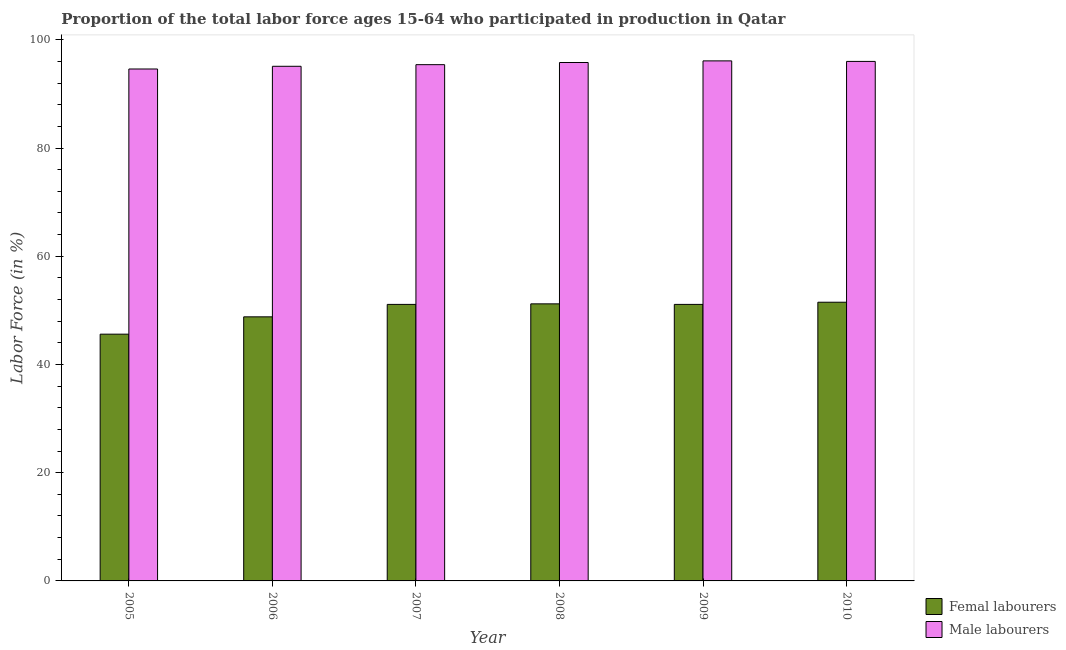How many bars are there on the 2nd tick from the left?
Offer a very short reply. 2. How many bars are there on the 4th tick from the right?
Your answer should be compact. 2. What is the label of the 2nd group of bars from the left?
Your answer should be compact. 2006. What is the percentage of male labour force in 2007?
Your answer should be very brief. 95.4. Across all years, what is the maximum percentage of female labor force?
Keep it short and to the point. 51.5. Across all years, what is the minimum percentage of male labour force?
Make the answer very short. 94.6. In which year was the percentage of male labour force maximum?
Your response must be concise. 2009. What is the total percentage of female labor force in the graph?
Your answer should be very brief. 299.3. What is the difference between the percentage of female labor force in 2008 and the percentage of male labour force in 2010?
Your answer should be very brief. -0.3. What is the average percentage of male labour force per year?
Your response must be concise. 95.5. What is the ratio of the percentage of female labor force in 2006 to that in 2007?
Provide a succinct answer. 0.95. Is the percentage of male labour force in 2005 less than that in 2006?
Provide a short and direct response. Yes. Is the difference between the percentage of male labour force in 2005 and 2008 greater than the difference between the percentage of female labor force in 2005 and 2008?
Make the answer very short. No. What is the difference between the highest and the second highest percentage of female labor force?
Your answer should be very brief. 0.3. What is the difference between the highest and the lowest percentage of female labor force?
Provide a succinct answer. 5.9. Is the sum of the percentage of female labor force in 2007 and 2008 greater than the maximum percentage of male labour force across all years?
Your answer should be very brief. Yes. What does the 2nd bar from the left in 2008 represents?
Your answer should be compact. Male labourers. What does the 1st bar from the right in 2007 represents?
Your answer should be compact. Male labourers. How many bars are there?
Keep it short and to the point. 12. Are all the bars in the graph horizontal?
Provide a succinct answer. No. How many years are there in the graph?
Offer a terse response. 6. Are the values on the major ticks of Y-axis written in scientific E-notation?
Keep it short and to the point. No. Does the graph contain grids?
Offer a very short reply. No. Where does the legend appear in the graph?
Your answer should be compact. Bottom right. How many legend labels are there?
Keep it short and to the point. 2. How are the legend labels stacked?
Ensure brevity in your answer.  Vertical. What is the title of the graph?
Your answer should be very brief. Proportion of the total labor force ages 15-64 who participated in production in Qatar. What is the label or title of the X-axis?
Ensure brevity in your answer.  Year. What is the label or title of the Y-axis?
Offer a terse response. Labor Force (in %). What is the Labor Force (in %) in Femal labourers in 2005?
Keep it short and to the point. 45.6. What is the Labor Force (in %) in Male labourers in 2005?
Provide a short and direct response. 94.6. What is the Labor Force (in %) in Femal labourers in 2006?
Make the answer very short. 48.8. What is the Labor Force (in %) of Male labourers in 2006?
Provide a succinct answer. 95.1. What is the Labor Force (in %) of Femal labourers in 2007?
Your response must be concise. 51.1. What is the Labor Force (in %) of Male labourers in 2007?
Ensure brevity in your answer.  95.4. What is the Labor Force (in %) in Femal labourers in 2008?
Ensure brevity in your answer.  51.2. What is the Labor Force (in %) in Male labourers in 2008?
Provide a short and direct response. 95.8. What is the Labor Force (in %) of Femal labourers in 2009?
Your answer should be compact. 51.1. What is the Labor Force (in %) of Male labourers in 2009?
Provide a succinct answer. 96.1. What is the Labor Force (in %) of Femal labourers in 2010?
Your response must be concise. 51.5. What is the Labor Force (in %) in Male labourers in 2010?
Your response must be concise. 96. Across all years, what is the maximum Labor Force (in %) in Femal labourers?
Make the answer very short. 51.5. Across all years, what is the maximum Labor Force (in %) in Male labourers?
Your response must be concise. 96.1. Across all years, what is the minimum Labor Force (in %) of Femal labourers?
Your response must be concise. 45.6. Across all years, what is the minimum Labor Force (in %) in Male labourers?
Keep it short and to the point. 94.6. What is the total Labor Force (in %) in Femal labourers in the graph?
Provide a succinct answer. 299.3. What is the total Labor Force (in %) in Male labourers in the graph?
Your response must be concise. 573. What is the difference between the Labor Force (in %) in Femal labourers in 2005 and that in 2006?
Keep it short and to the point. -3.2. What is the difference between the Labor Force (in %) in Male labourers in 2005 and that in 2006?
Keep it short and to the point. -0.5. What is the difference between the Labor Force (in %) in Femal labourers in 2005 and that in 2007?
Your answer should be very brief. -5.5. What is the difference between the Labor Force (in %) of Femal labourers in 2005 and that in 2008?
Your answer should be very brief. -5.6. What is the difference between the Labor Force (in %) in Male labourers in 2005 and that in 2008?
Keep it short and to the point. -1.2. What is the difference between the Labor Force (in %) in Male labourers in 2005 and that in 2009?
Provide a short and direct response. -1.5. What is the difference between the Labor Force (in %) of Male labourers in 2006 and that in 2007?
Give a very brief answer. -0.3. What is the difference between the Labor Force (in %) of Femal labourers in 2006 and that in 2008?
Provide a succinct answer. -2.4. What is the difference between the Labor Force (in %) in Femal labourers in 2006 and that in 2009?
Your response must be concise. -2.3. What is the difference between the Labor Force (in %) of Male labourers in 2006 and that in 2009?
Your answer should be very brief. -1. What is the difference between the Labor Force (in %) of Femal labourers in 2006 and that in 2010?
Offer a very short reply. -2.7. What is the difference between the Labor Force (in %) of Male labourers in 2007 and that in 2009?
Offer a terse response. -0.7. What is the difference between the Labor Force (in %) of Femal labourers in 2007 and that in 2010?
Offer a terse response. -0.4. What is the difference between the Labor Force (in %) of Male labourers in 2007 and that in 2010?
Your answer should be compact. -0.6. What is the difference between the Labor Force (in %) of Femal labourers in 2008 and that in 2009?
Keep it short and to the point. 0.1. What is the difference between the Labor Force (in %) in Male labourers in 2008 and that in 2009?
Provide a succinct answer. -0.3. What is the difference between the Labor Force (in %) in Femal labourers in 2008 and that in 2010?
Provide a short and direct response. -0.3. What is the difference between the Labor Force (in %) in Male labourers in 2008 and that in 2010?
Your answer should be compact. -0.2. What is the difference between the Labor Force (in %) in Male labourers in 2009 and that in 2010?
Give a very brief answer. 0.1. What is the difference between the Labor Force (in %) in Femal labourers in 2005 and the Labor Force (in %) in Male labourers in 2006?
Your response must be concise. -49.5. What is the difference between the Labor Force (in %) in Femal labourers in 2005 and the Labor Force (in %) in Male labourers in 2007?
Your answer should be very brief. -49.8. What is the difference between the Labor Force (in %) in Femal labourers in 2005 and the Labor Force (in %) in Male labourers in 2008?
Keep it short and to the point. -50.2. What is the difference between the Labor Force (in %) in Femal labourers in 2005 and the Labor Force (in %) in Male labourers in 2009?
Provide a short and direct response. -50.5. What is the difference between the Labor Force (in %) in Femal labourers in 2005 and the Labor Force (in %) in Male labourers in 2010?
Offer a terse response. -50.4. What is the difference between the Labor Force (in %) in Femal labourers in 2006 and the Labor Force (in %) in Male labourers in 2007?
Make the answer very short. -46.6. What is the difference between the Labor Force (in %) in Femal labourers in 2006 and the Labor Force (in %) in Male labourers in 2008?
Make the answer very short. -47. What is the difference between the Labor Force (in %) in Femal labourers in 2006 and the Labor Force (in %) in Male labourers in 2009?
Your answer should be very brief. -47.3. What is the difference between the Labor Force (in %) of Femal labourers in 2006 and the Labor Force (in %) of Male labourers in 2010?
Give a very brief answer. -47.2. What is the difference between the Labor Force (in %) of Femal labourers in 2007 and the Labor Force (in %) of Male labourers in 2008?
Your response must be concise. -44.7. What is the difference between the Labor Force (in %) of Femal labourers in 2007 and the Labor Force (in %) of Male labourers in 2009?
Your answer should be compact. -45. What is the difference between the Labor Force (in %) of Femal labourers in 2007 and the Labor Force (in %) of Male labourers in 2010?
Give a very brief answer. -44.9. What is the difference between the Labor Force (in %) of Femal labourers in 2008 and the Labor Force (in %) of Male labourers in 2009?
Provide a succinct answer. -44.9. What is the difference between the Labor Force (in %) in Femal labourers in 2008 and the Labor Force (in %) in Male labourers in 2010?
Provide a short and direct response. -44.8. What is the difference between the Labor Force (in %) in Femal labourers in 2009 and the Labor Force (in %) in Male labourers in 2010?
Offer a terse response. -44.9. What is the average Labor Force (in %) of Femal labourers per year?
Your answer should be very brief. 49.88. What is the average Labor Force (in %) in Male labourers per year?
Give a very brief answer. 95.5. In the year 2005, what is the difference between the Labor Force (in %) of Femal labourers and Labor Force (in %) of Male labourers?
Give a very brief answer. -49. In the year 2006, what is the difference between the Labor Force (in %) in Femal labourers and Labor Force (in %) in Male labourers?
Provide a short and direct response. -46.3. In the year 2007, what is the difference between the Labor Force (in %) in Femal labourers and Labor Force (in %) in Male labourers?
Your answer should be very brief. -44.3. In the year 2008, what is the difference between the Labor Force (in %) of Femal labourers and Labor Force (in %) of Male labourers?
Provide a short and direct response. -44.6. In the year 2009, what is the difference between the Labor Force (in %) in Femal labourers and Labor Force (in %) in Male labourers?
Provide a short and direct response. -45. In the year 2010, what is the difference between the Labor Force (in %) of Femal labourers and Labor Force (in %) of Male labourers?
Your response must be concise. -44.5. What is the ratio of the Labor Force (in %) in Femal labourers in 2005 to that in 2006?
Provide a succinct answer. 0.93. What is the ratio of the Labor Force (in %) of Femal labourers in 2005 to that in 2007?
Provide a short and direct response. 0.89. What is the ratio of the Labor Force (in %) in Femal labourers in 2005 to that in 2008?
Provide a succinct answer. 0.89. What is the ratio of the Labor Force (in %) of Male labourers in 2005 to that in 2008?
Your answer should be compact. 0.99. What is the ratio of the Labor Force (in %) in Femal labourers in 2005 to that in 2009?
Your response must be concise. 0.89. What is the ratio of the Labor Force (in %) of Male labourers in 2005 to that in 2009?
Your response must be concise. 0.98. What is the ratio of the Labor Force (in %) in Femal labourers in 2005 to that in 2010?
Keep it short and to the point. 0.89. What is the ratio of the Labor Force (in %) of Male labourers in 2005 to that in 2010?
Your answer should be compact. 0.99. What is the ratio of the Labor Force (in %) in Femal labourers in 2006 to that in 2007?
Offer a terse response. 0.95. What is the ratio of the Labor Force (in %) of Male labourers in 2006 to that in 2007?
Provide a short and direct response. 1. What is the ratio of the Labor Force (in %) in Femal labourers in 2006 to that in 2008?
Provide a succinct answer. 0.95. What is the ratio of the Labor Force (in %) in Femal labourers in 2006 to that in 2009?
Provide a succinct answer. 0.95. What is the ratio of the Labor Force (in %) of Male labourers in 2006 to that in 2009?
Give a very brief answer. 0.99. What is the ratio of the Labor Force (in %) in Femal labourers in 2006 to that in 2010?
Your answer should be compact. 0.95. What is the ratio of the Labor Force (in %) in Male labourers in 2006 to that in 2010?
Provide a short and direct response. 0.99. What is the ratio of the Labor Force (in %) of Femal labourers in 2007 to that in 2008?
Provide a succinct answer. 1. What is the ratio of the Labor Force (in %) of Male labourers in 2007 to that in 2008?
Offer a terse response. 1. What is the ratio of the Labor Force (in %) in Male labourers in 2007 to that in 2009?
Give a very brief answer. 0.99. What is the ratio of the Labor Force (in %) in Femal labourers in 2007 to that in 2010?
Make the answer very short. 0.99. What is the ratio of the Labor Force (in %) of Femal labourers in 2008 to that in 2009?
Provide a succinct answer. 1. What is the ratio of the Labor Force (in %) in Male labourers in 2008 to that in 2009?
Your answer should be very brief. 1. What is the difference between the highest and the second highest Labor Force (in %) of Male labourers?
Offer a very short reply. 0.1. What is the difference between the highest and the lowest Labor Force (in %) of Male labourers?
Your answer should be very brief. 1.5. 